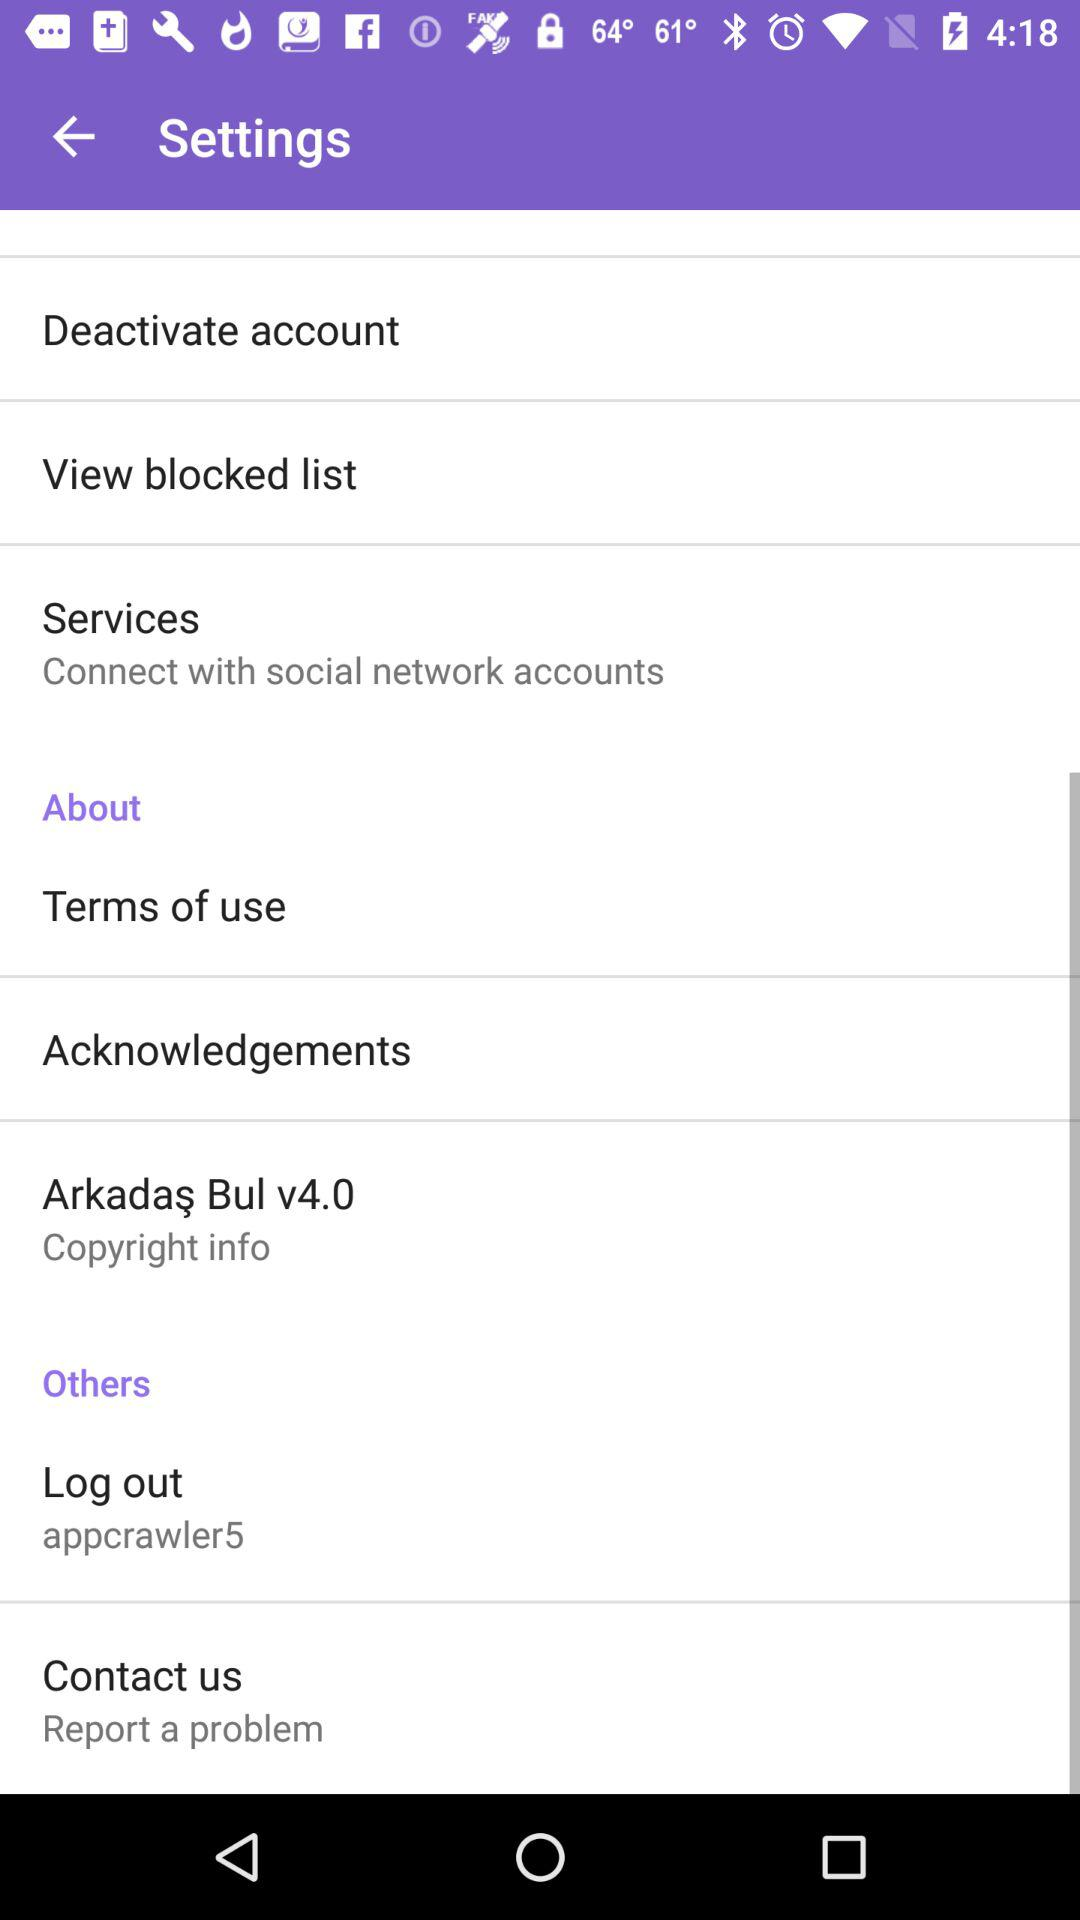What is the username? The username is "appcrawler5". 